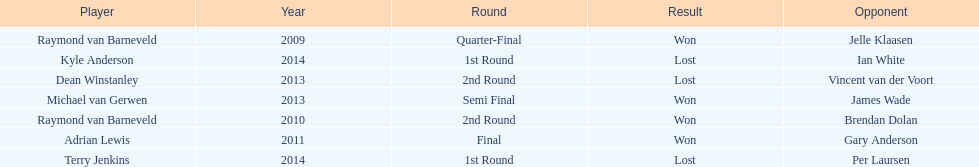Other than kyle anderson, who else lost in 2014? Terry Jenkins. Write the full table. {'header': ['Player', 'Year', 'Round', 'Result', 'Opponent'], 'rows': [['Raymond van Barneveld', '2009', 'Quarter-Final', 'Won', 'Jelle Klaasen'], ['Kyle Anderson', '2014', '1st Round', 'Lost', 'Ian White'], ['Dean Winstanley', '2013', '2nd Round', 'Lost', 'Vincent van der Voort'], ['Michael van Gerwen', '2013', 'Semi Final', 'Won', 'James Wade'], ['Raymond van Barneveld', '2010', '2nd Round', 'Won', 'Brendan Dolan'], ['Adrian Lewis', '2011', 'Final', 'Won', 'Gary Anderson'], ['Terry Jenkins', '2014', '1st Round', 'Lost', 'Per Laursen']]} 